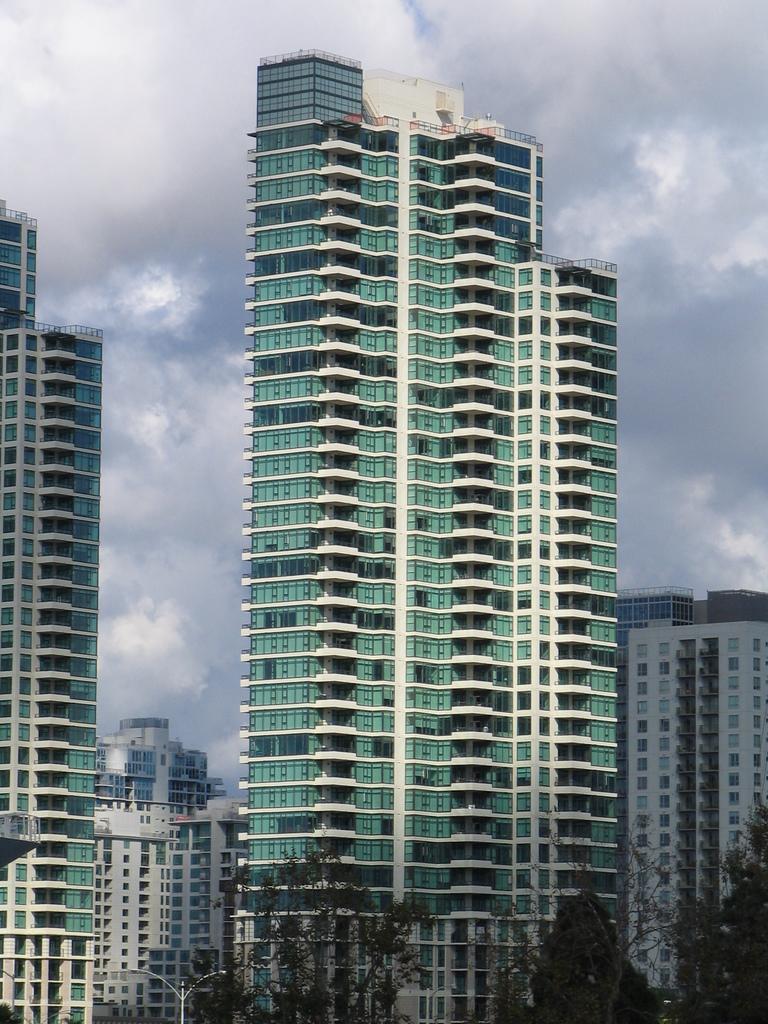Can you describe this image briefly? There are many buildings. At the bottom there are many trees and light pole. In the background there is sky with clouds. 